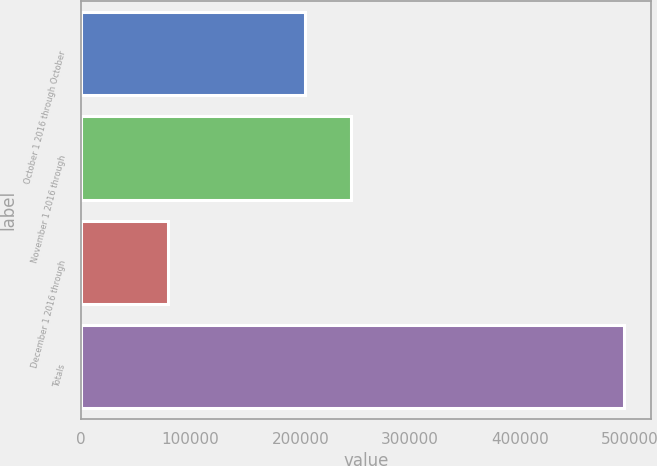<chart> <loc_0><loc_0><loc_500><loc_500><bar_chart><fcel>October 1 2016 through October<fcel>November 1 2016 through<fcel>December 1 2016 through<fcel>Totals<nl><fcel>204350<fcel>245892<fcel>79435<fcel>494856<nl></chart> 